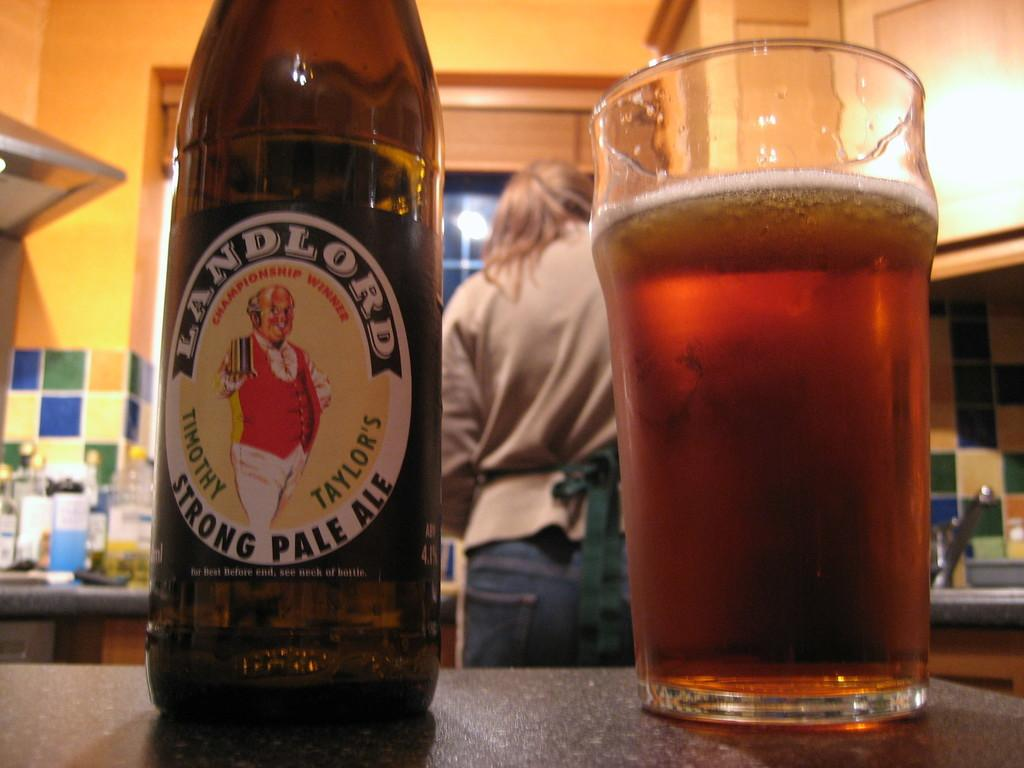What type of beverage is present in the image? There is a beer bottle and a glass with beer in the image. Where are the beer bottle and glass located? Both the bottle and glass are on a table. Is there anyone else present in the image besides the beverages? Yes, there is a person standing in the image. What type of needle is being used by the person in the image? There is no needle present in the image; it features a beer bottle and around the glass and bottle. 